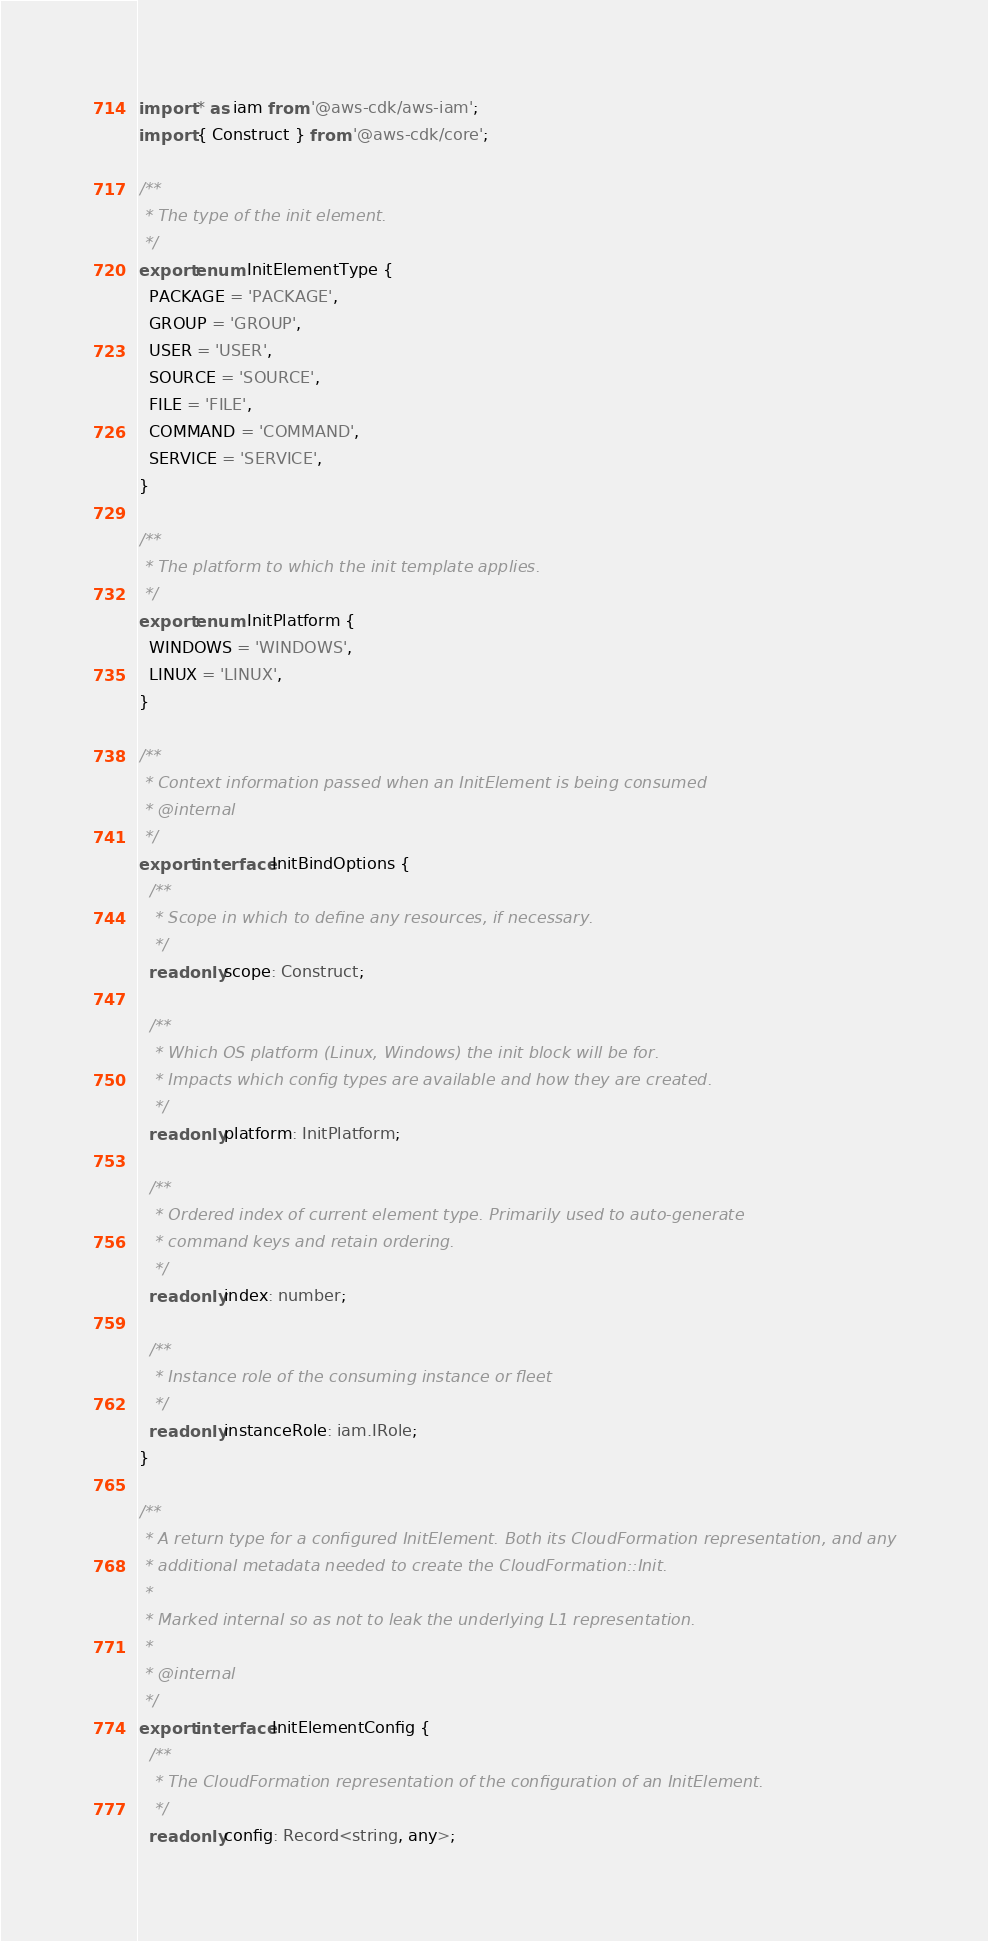<code> <loc_0><loc_0><loc_500><loc_500><_TypeScript_>import * as iam from '@aws-cdk/aws-iam';
import { Construct } from '@aws-cdk/core';

/**
 * The type of the init element.
 */
export enum InitElementType {
  PACKAGE = 'PACKAGE',
  GROUP = 'GROUP',
  USER = 'USER',
  SOURCE = 'SOURCE',
  FILE = 'FILE',
  COMMAND = 'COMMAND',
  SERVICE = 'SERVICE',
}

/**
 * The platform to which the init template applies.
 */
export enum InitPlatform {
  WINDOWS = 'WINDOWS',
  LINUX = 'LINUX',
}

/**
 * Context information passed when an InitElement is being consumed
 * @internal
 */
export interface InitBindOptions {
  /**
   * Scope in which to define any resources, if necessary.
   */
  readonly scope: Construct;

  /**
   * Which OS platform (Linux, Windows) the init block will be for.
   * Impacts which config types are available and how they are created.
   */
  readonly platform: InitPlatform;

  /**
   * Ordered index of current element type. Primarily used to auto-generate
   * command keys and retain ordering.
   */
  readonly index: number;

  /**
   * Instance role of the consuming instance or fleet
   */
  readonly instanceRole: iam.IRole;
}

/**
 * A return type for a configured InitElement. Both its CloudFormation representation, and any
 * additional metadata needed to create the CloudFormation::Init.
 *
 * Marked internal so as not to leak the underlying L1 representation.
 *
 * @internal
 */
export interface InitElementConfig {
  /**
   * The CloudFormation representation of the configuration of an InitElement.
   */
  readonly config: Record<string, any>;
</code> 